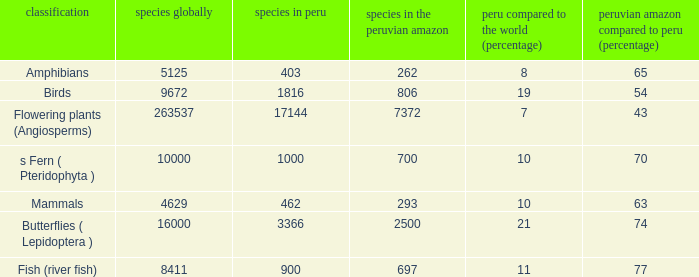What's the minimum species in the peruvian amazon with taxonomy s fern ( pteridophyta ) 700.0. 